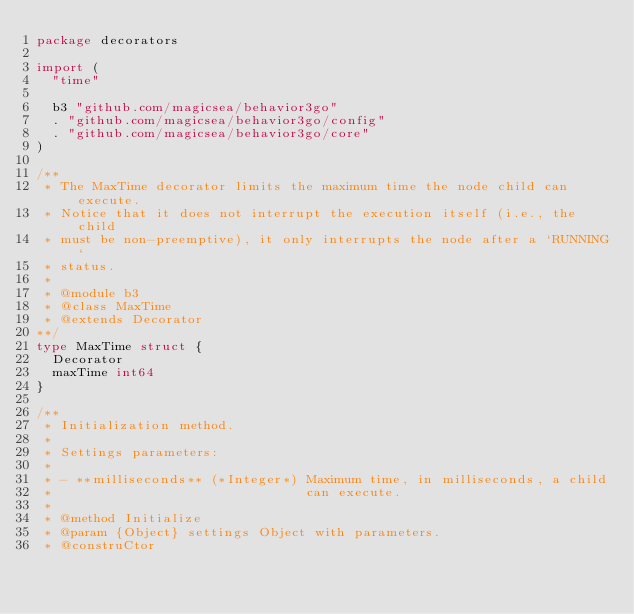<code> <loc_0><loc_0><loc_500><loc_500><_Go_>package decorators

import (
	"time"

	b3 "github.com/magicsea/behavior3go"
	. "github.com/magicsea/behavior3go/config"
	. "github.com/magicsea/behavior3go/core"
)

/**
 * The MaxTime decorator limits the maximum time the node child can execute.
 * Notice that it does not interrupt the execution itself (i.e., the child
 * must be non-preemptive), it only interrupts the node after a `RUNNING`
 * status.
 *
 * @module b3
 * @class MaxTime
 * @extends Decorator
**/
type MaxTime struct {
	Decorator
	maxTime int64
}

/**
 * Initialization method.
 *
 * Settings parameters:
 *
 * - **milliseconds** (*Integer*) Maximum time, in milliseconds, a child
 *                                can execute.
 *
 * @method Initialize
 * @param {Object} settings Object with parameters.
 * @construCtor</code> 